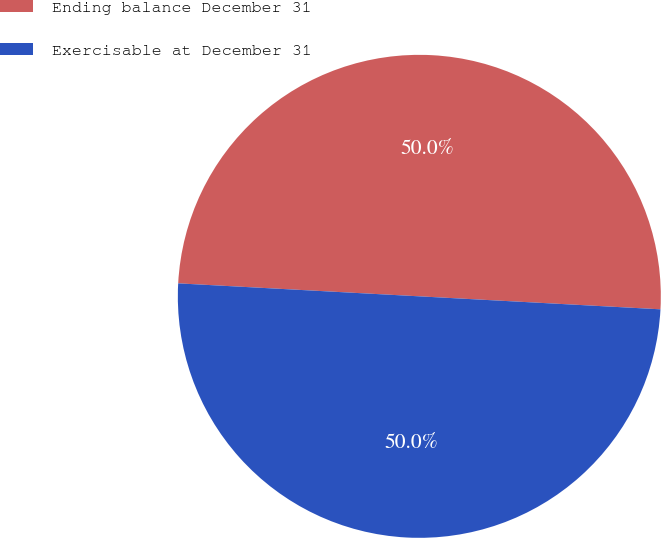<chart> <loc_0><loc_0><loc_500><loc_500><pie_chart><fcel>Ending balance December 31<fcel>Exercisable at December 31<nl><fcel>50.0%<fcel>50.0%<nl></chart> 